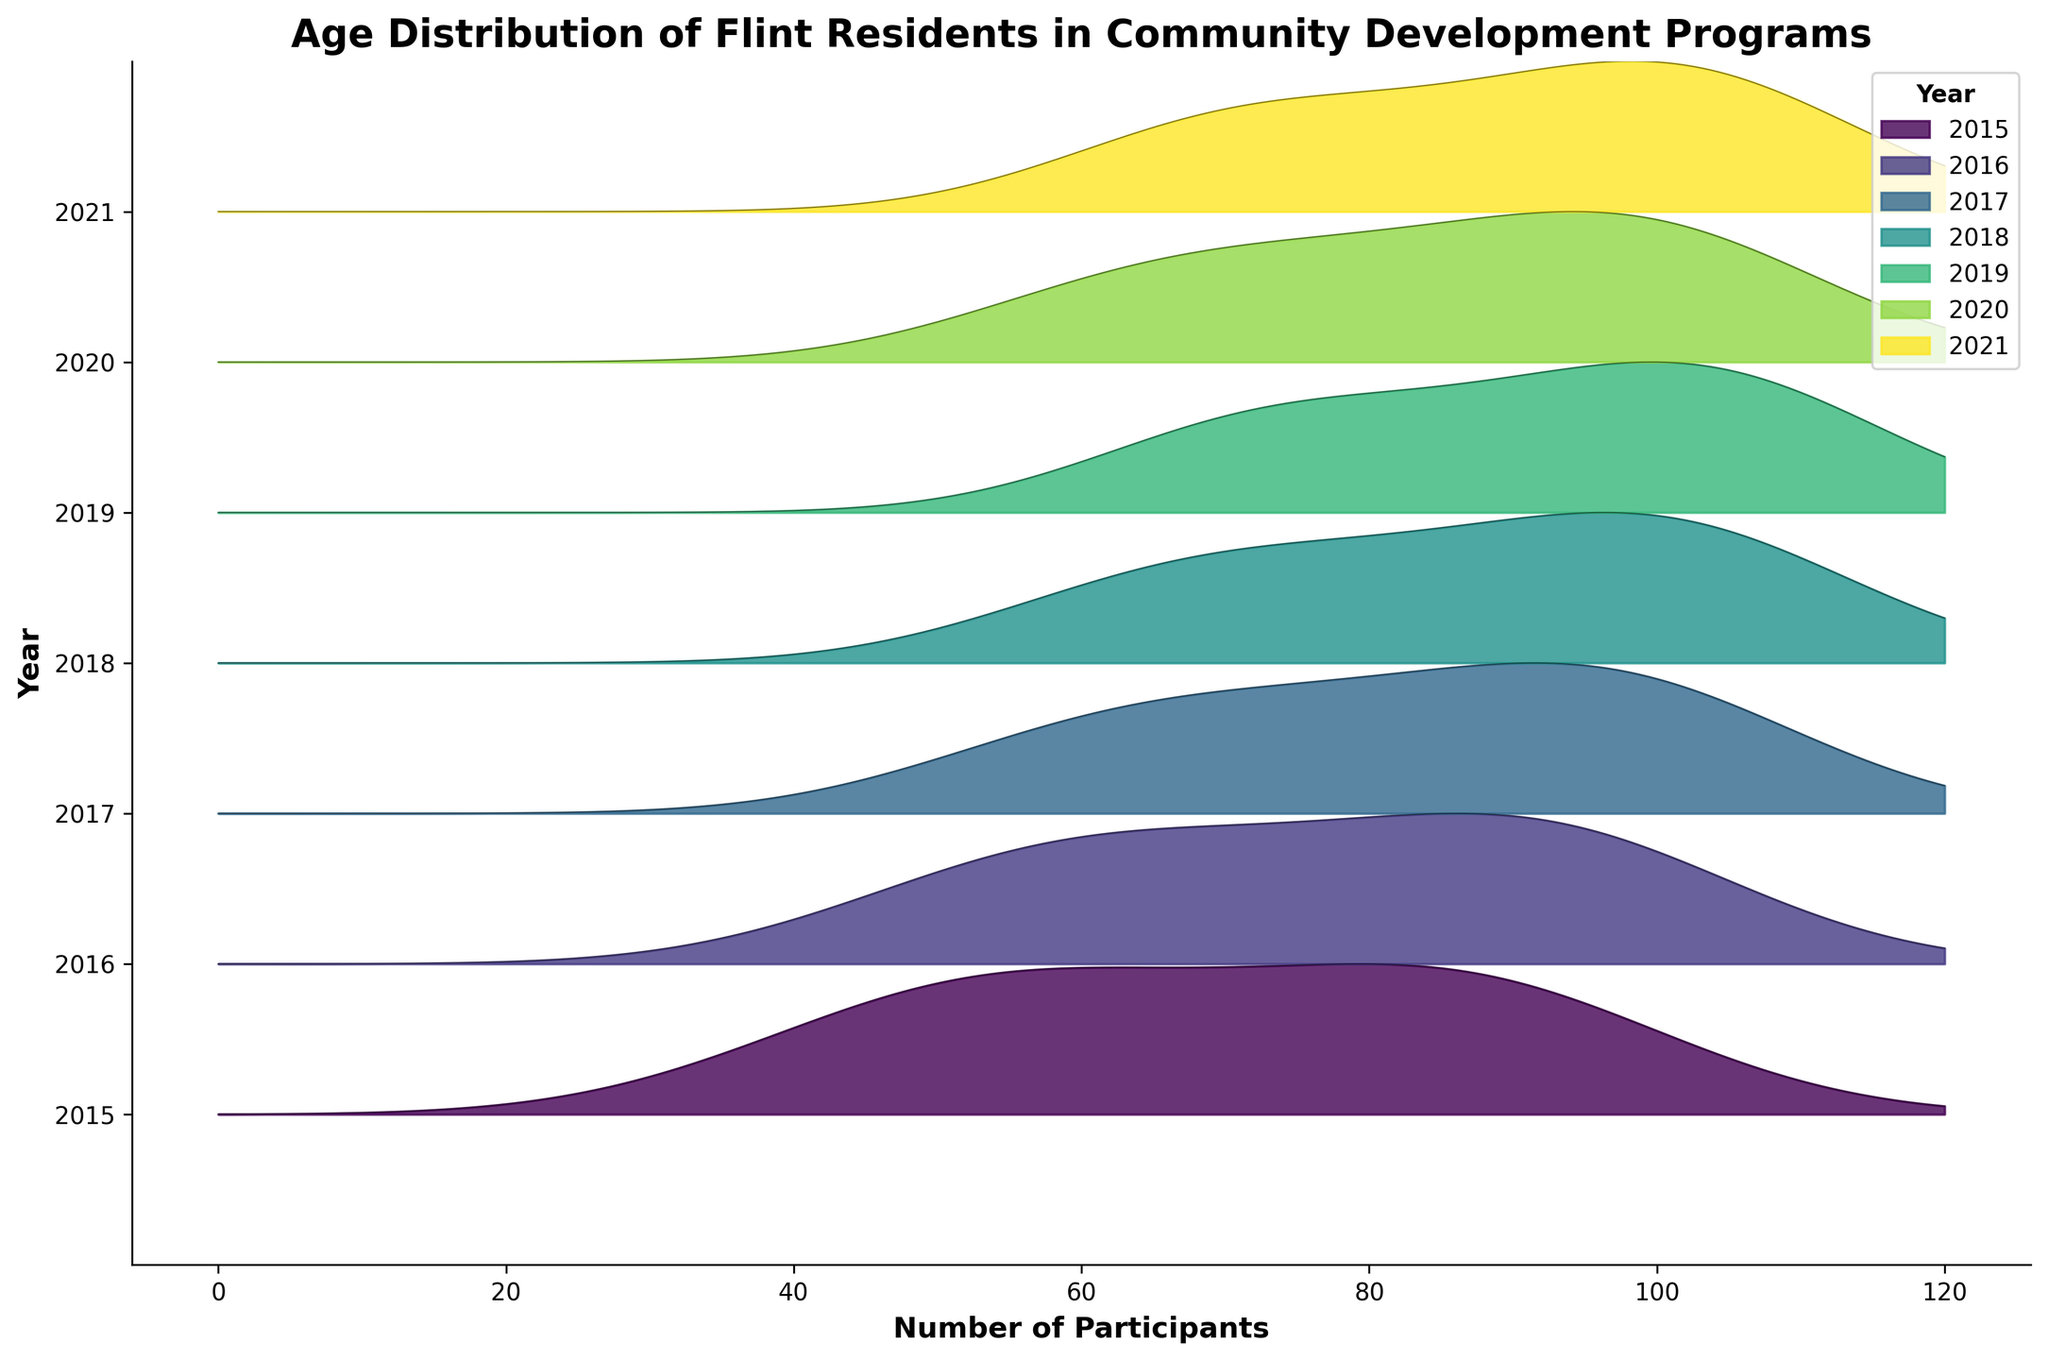What is the title of the figure? The title is typically displayed at the top of the figure. You can read it directly from the plot.
Answer: Age Distribution of Flint Residents in Community Development Programs In which year did the 45-54 age group have the highest number of participants? Look at the plot lines and filled areas for different years and compare the height of the peaks corresponding to the 45-54 age group.
Answer: 2019 How many age groups are displayed in the plot? Count the distinct age group labels from the ridgeline plot.
Answer: 6 Which year shows the smallest peak for participants in the 18-24 age group? Compare the height of the peaks for the 18-24 age group across different years. The smallest peak corresponds to the year with the least participants in that age group.
Answer: 2015 Compare the number of participants in the 65+ age group between 2020 and 2021. Which year had more participants? Check the position and height of the peaks for the 65+ age group for the years 2020 and 2021 and see which peak is higher.
Answer: 2021 What age group has a consistent increase in participants every year from 2015 to 2021? Examine the heights of the peaks for each age group from 2015 to 2021 and identify which age group's peaks are increasing each year.
Answer: 25-34 Based on the ridgeline plot, what can you infer about the overall trend in the participation of the residents aged 45-54 from 2015 to 2021? Check the progression of the peaks for the 45-54 age group. The consistent increase in peak height year over year suggests a growing trend.
Answer: Increasing What is the overall participation trend for residents aged 55-64 from 2015 to 2021? Observe the height of the peaks associated with the 55-64 age group across the years. Focus on whether they generally increase, decrease, or remain stable.
Answer: Increasing Which year has a noticeably lower number of participants in the 25-34 age group compared to the other years? Compare the peaks for the 25-34 age group across all years and identify if there is a year with a distinctly smaller peak.
Answer: 2015 